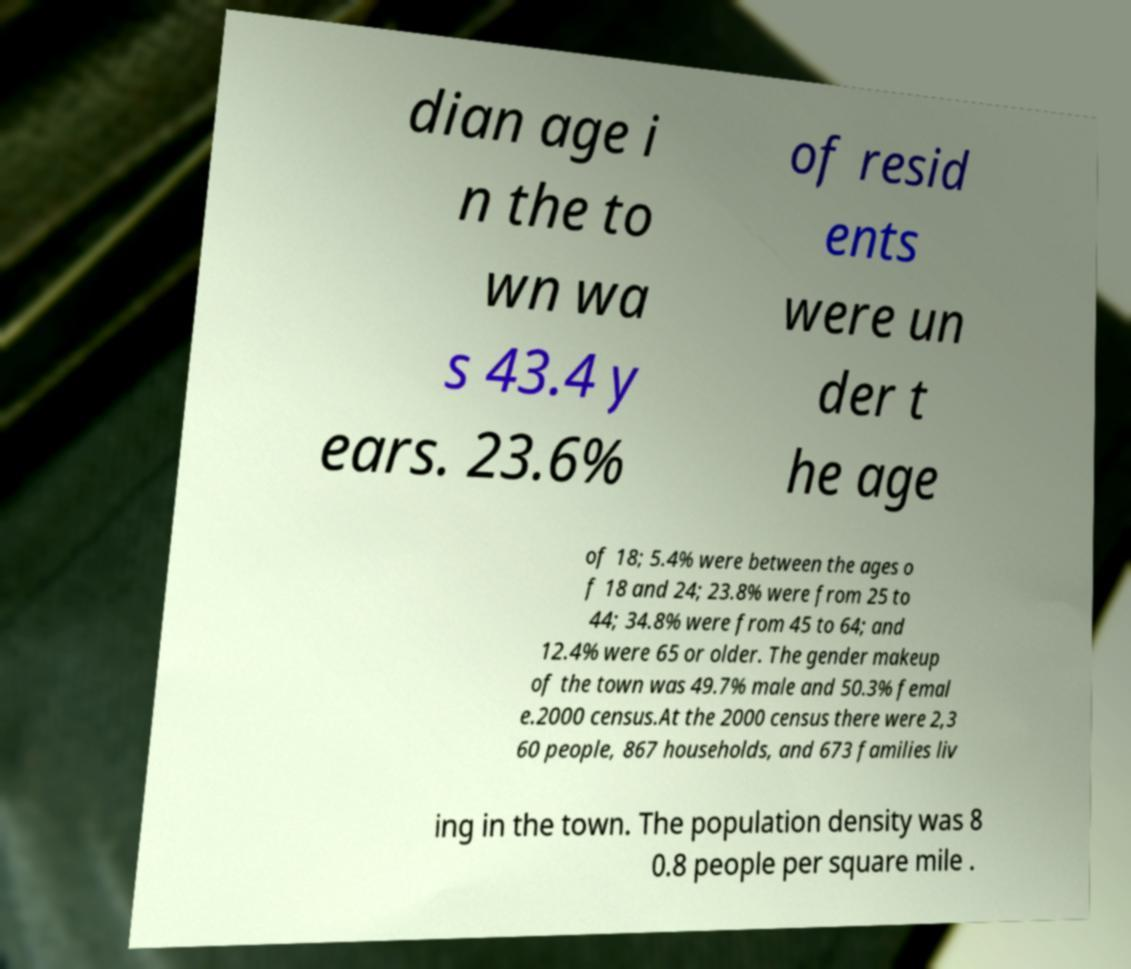Please identify and transcribe the text found in this image. dian age i n the to wn wa s 43.4 y ears. 23.6% of resid ents were un der t he age of 18; 5.4% were between the ages o f 18 and 24; 23.8% were from 25 to 44; 34.8% were from 45 to 64; and 12.4% were 65 or older. The gender makeup of the town was 49.7% male and 50.3% femal e.2000 census.At the 2000 census there were 2,3 60 people, 867 households, and 673 families liv ing in the town. The population density was 8 0.8 people per square mile . 